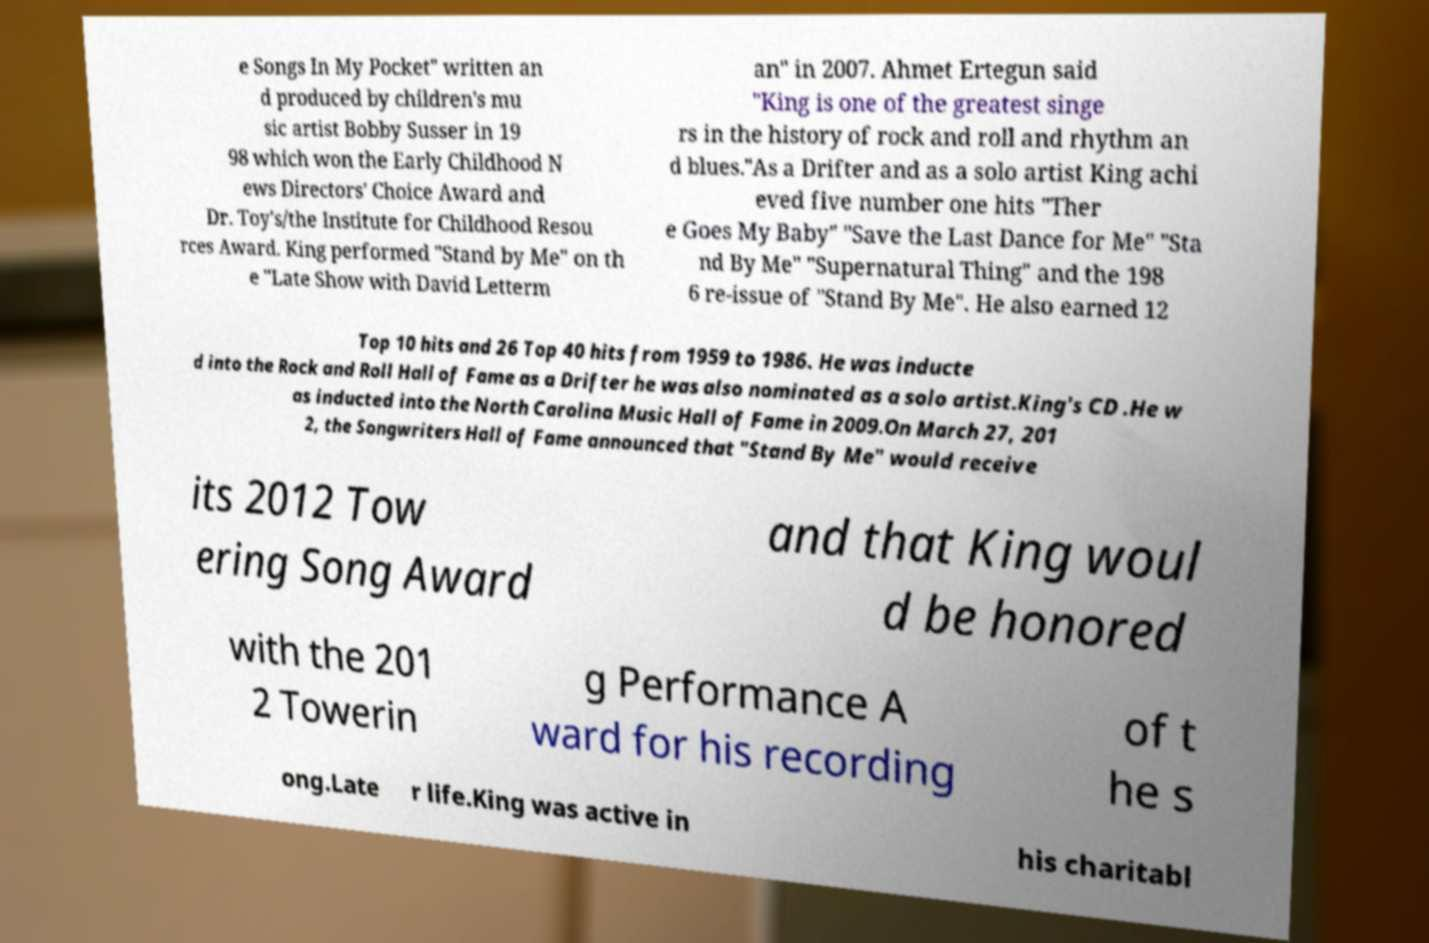Please identify and transcribe the text found in this image. e Songs In My Pocket" written an d produced by children's mu sic artist Bobby Susser in 19 98 which won the Early Childhood N ews Directors' Choice Award and Dr. Toy's/the Institute for Childhood Resou rces Award. King performed "Stand by Me" on th e "Late Show with David Letterm an" in 2007. Ahmet Ertegun said "King is one of the greatest singe rs in the history of rock and roll and rhythm an d blues."As a Drifter and as a solo artist King achi eved five number one hits "Ther e Goes My Baby" "Save the Last Dance for Me" "Sta nd By Me" "Supernatural Thing" and the 198 6 re-issue of "Stand By Me". He also earned 12 Top 10 hits and 26 Top 40 hits from 1959 to 1986. He was inducte d into the Rock and Roll Hall of Fame as a Drifter he was also nominated as a solo artist.King's CD .He w as inducted into the North Carolina Music Hall of Fame in 2009.On March 27, 201 2, the Songwriters Hall of Fame announced that "Stand By Me" would receive its 2012 Tow ering Song Award and that King woul d be honored with the 201 2 Towerin g Performance A ward for his recording of t he s ong.Late r life.King was active in his charitabl 